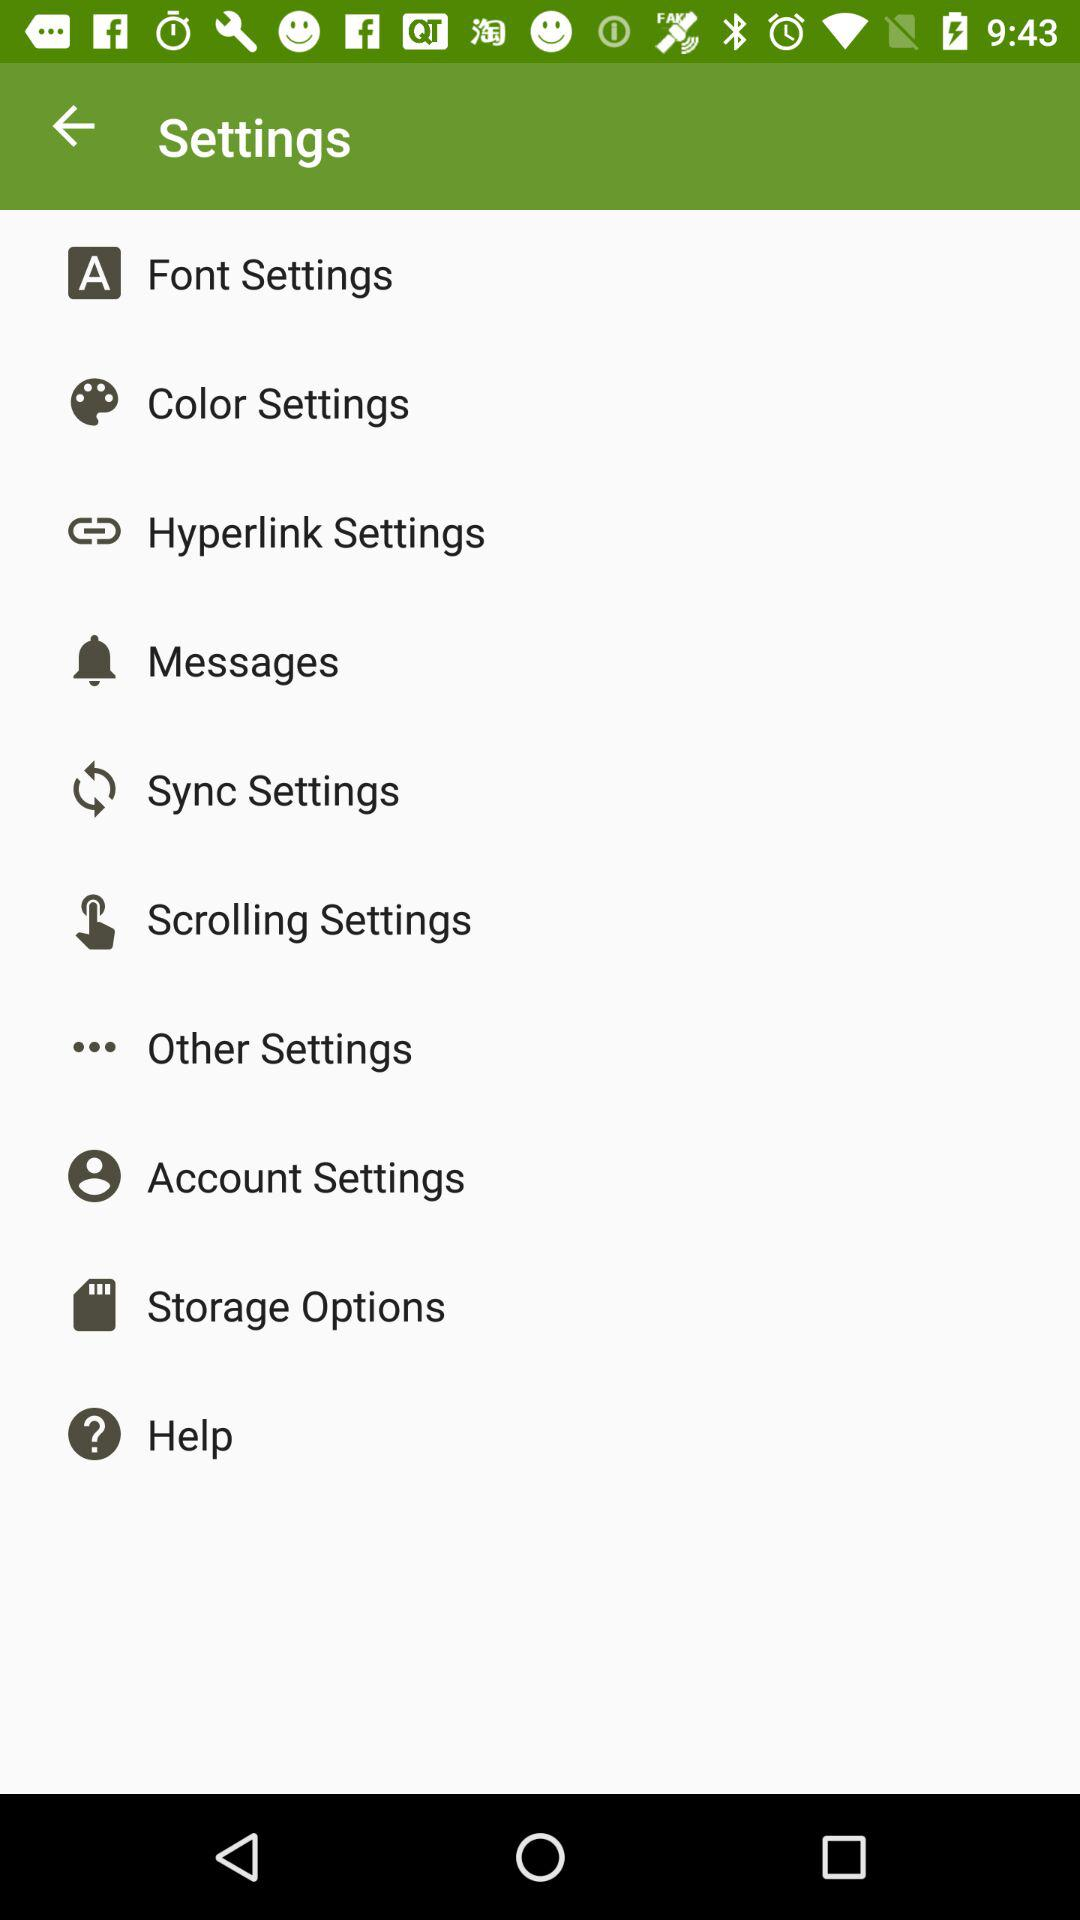How many items are in the settings menu?
Answer the question using a single word or phrase. 10 